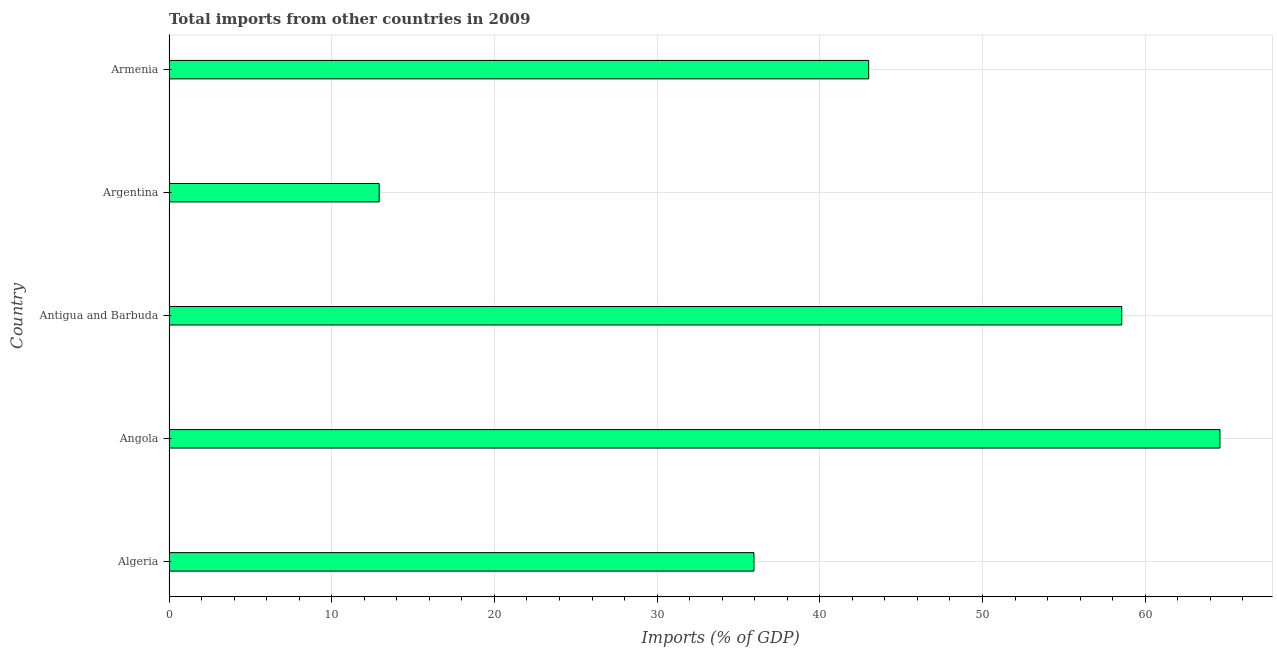Does the graph contain any zero values?
Make the answer very short. No. Does the graph contain grids?
Your answer should be compact. Yes. What is the title of the graph?
Offer a very short reply. Total imports from other countries in 2009. What is the label or title of the X-axis?
Give a very brief answer. Imports (% of GDP). What is the label or title of the Y-axis?
Your response must be concise. Country. What is the total imports in Argentina?
Ensure brevity in your answer.  12.92. Across all countries, what is the maximum total imports?
Provide a succinct answer. 64.6. Across all countries, what is the minimum total imports?
Make the answer very short. 12.92. In which country was the total imports maximum?
Ensure brevity in your answer.  Angola. In which country was the total imports minimum?
Give a very brief answer. Argentina. What is the sum of the total imports?
Ensure brevity in your answer.  215.03. What is the difference between the total imports in Argentina and Armenia?
Offer a terse response. -30.09. What is the average total imports per country?
Ensure brevity in your answer.  43.01. What is the median total imports?
Your answer should be compact. 43. What is the ratio of the total imports in Argentina to that in Armenia?
Your answer should be very brief. 0.3. What is the difference between the highest and the second highest total imports?
Provide a succinct answer. 6.04. What is the difference between the highest and the lowest total imports?
Give a very brief answer. 51.68. How many countries are there in the graph?
Provide a succinct answer. 5. What is the difference between two consecutive major ticks on the X-axis?
Your answer should be compact. 10. Are the values on the major ticks of X-axis written in scientific E-notation?
Your answer should be compact. No. What is the Imports (% of GDP) of Algeria?
Offer a terse response. 35.95. What is the Imports (% of GDP) of Angola?
Offer a very short reply. 64.6. What is the Imports (% of GDP) of Antigua and Barbuda?
Your answer should be compact. 58.56. What is the Imports (% of GDP) in Argentina?
Your answer should be compact. 12.92. What is the Imports (% of GDP) in Armenia?
Your response must be concise. 43. What is the difference between the Imports (% of GDP) in Algeria and Angola?
Provide a succinct answer. -28.64. What is the difference between the Imports (% of GDP) in Algeria and Antigua and Barbuda?
Offer a terse response. -22.61. What is the difference between the Imports (% of GDP) in Algeria and Argentina?
Your answer should be compact. 23.03. What is the difference between the Imports (% of GDP) in Algeria and Armenia?
Offer a terse response. -7.05. What is the difference between the Imports (% of GDP) in Angola and Antigua and Barbuda?
Make the answer very short. 6.04. What is the difference between the Imports (% of GDP) in Angola and Argentina?
Offer a terse response. 51.68. What is the difference between the Imports (% of GDP) in Angola and Armenia?
Offer a very short reply. 21.59. What is the difference between the Imports (% of GDP) in Antigua and Barbuda and Argentina?
Offer a very short reply. 45.64. What is the difference between the Imports (% of GDP) in Antigua and Barbuda and Armenia?
Your answer should be very brief. 15.56. What is the difference between the Imports (% of GDP) in Argentina and Armenia?
Your answer should be very brief. -30.09. What is the ratio of the Imports (% of GDP) in Algeria to that in Angola?
Provide a succinct answer. 0.56. What is the ratio of the Imports (% of GDP) in Algeria to that in Antigua and Barbuda?
Offer a terse response. 0.61. What is the ratio of the Imports (% of GDP) in Algeria to that in Argentina?
Provide a succinct answer. 2.78. What is the ratio of the Imports (% of GDP) in Algeria to that in Armenia?
Your answer should be compact. 0.84. What is the ratio of the Imports (% of GDP) in Angola to that in Antigua and Barbuda?
Your answer should be compact. 1.1. What is the ratio of the Imports (% of GDP) in Angola to that in Argentina?
Ensure brevity in your answer.  5. What is the ratio of the Imports (% of GDP) in Angola to that in Armenia?
Your response must be concise. 1.5. What is the ratio of the Imports (% of GDP) in Antigua and Barbuda to that in Argentina?
Ensure brevity in your answer.  4.53. What is the ratio of the Imports (% of GDP) in Antigua and Barbuda to that in Armenia?
Make the answer very short. 1.36. 